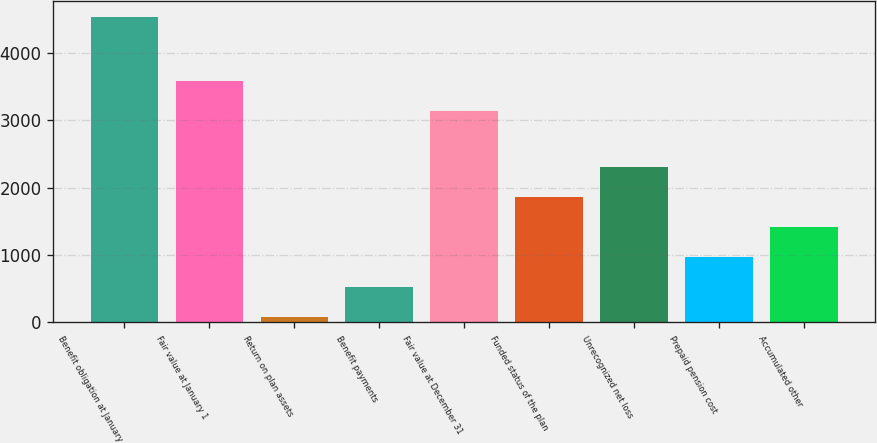Convert chart. <chart><loc_0><loc_0><loc_500><loc_500><bar_chart><fcel>Benefit obligation at January<fcel>Fair value at January 1<fcel>Return on plan assets<fcel>Benefit payments<fcel>Fair value at December 31<fcel>Funded status of the plan<fcel>Unrecognized net loss<fcel>Prepaid pension cost<fcel>Accumulated other<nl><fcel>4536<fcel>3575.2<fcel>84<fcel>529.2<fcel>3130<fcel>1864.8<fcel>2310<fcel>974.4<fcel>1419.6<nl></chart> 